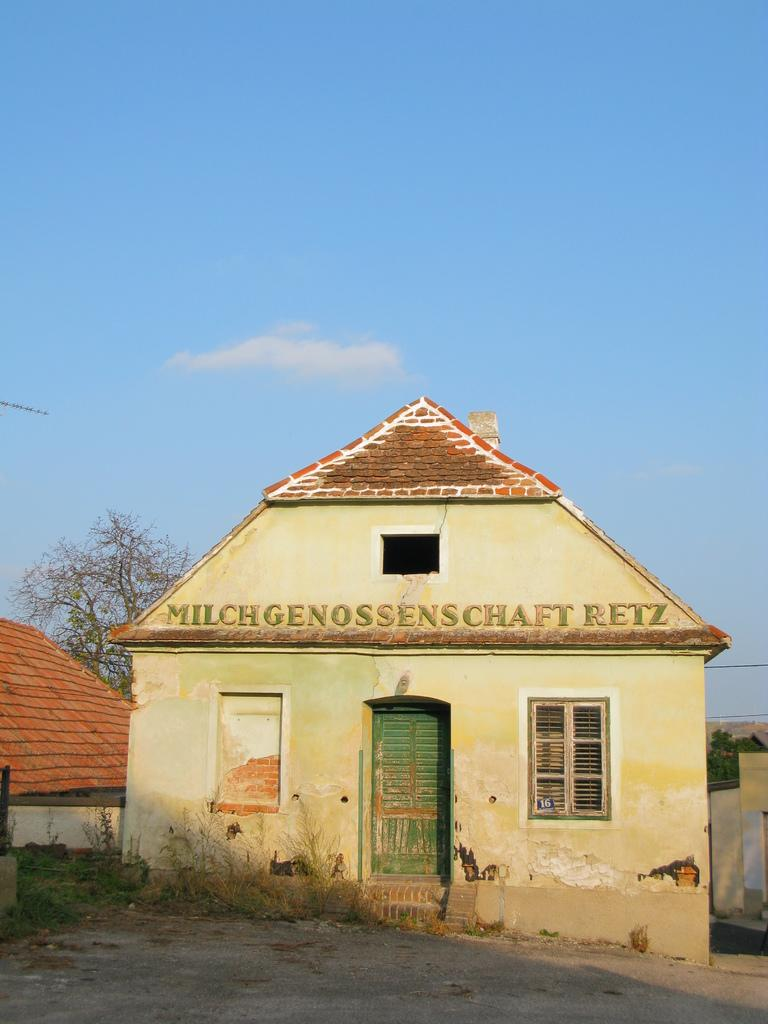What type of structure is visible in the image? There is a house in the image. What type of vegetation is present in the image? There is grass and a tree in the image. What else can be seen in the image besides the house and vegetation? There are wires in the image. What is visible in the background of the image? The sky is visible in the background of the image, and there are clouds in the sky. How many fingers can be seen pointing at the tree in the image? There are no fingers visible in the image, as it only features a house, grass, a tree, wires, and the sky with clouds. 